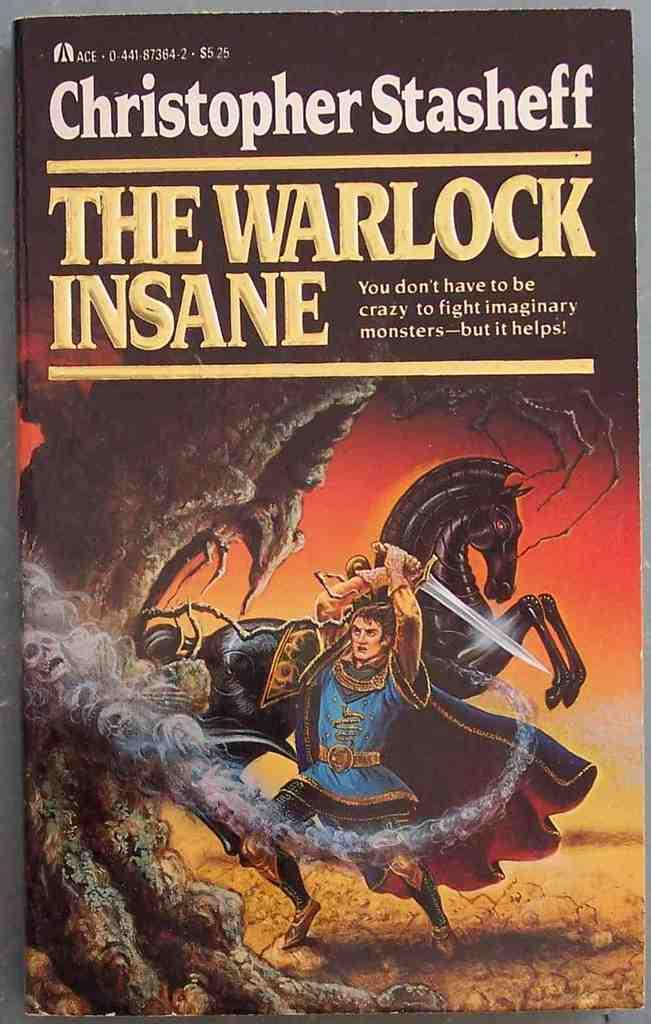<image>
Create a compact narrative representing the image presented. A book written by Christopher Stasheff called the Warlock Insane. 